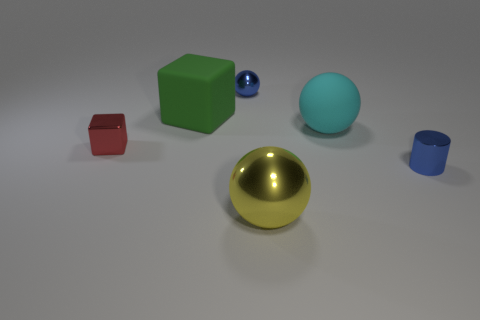Add 2 red shiny cylinders. How many objects exist? 8 Subtract all cylinders. How many objects are left? 5 Add 1 large purple balls. How many large purple balls exist? 1 Subtract 0 purple cylinders. How many objects are left? 6 Subtract all yellow shiny blocks. Subtract all big matte blocks. How many objects are left? 5 Add 1 tiny cylinders. How many tiny cylinders are left? 2 